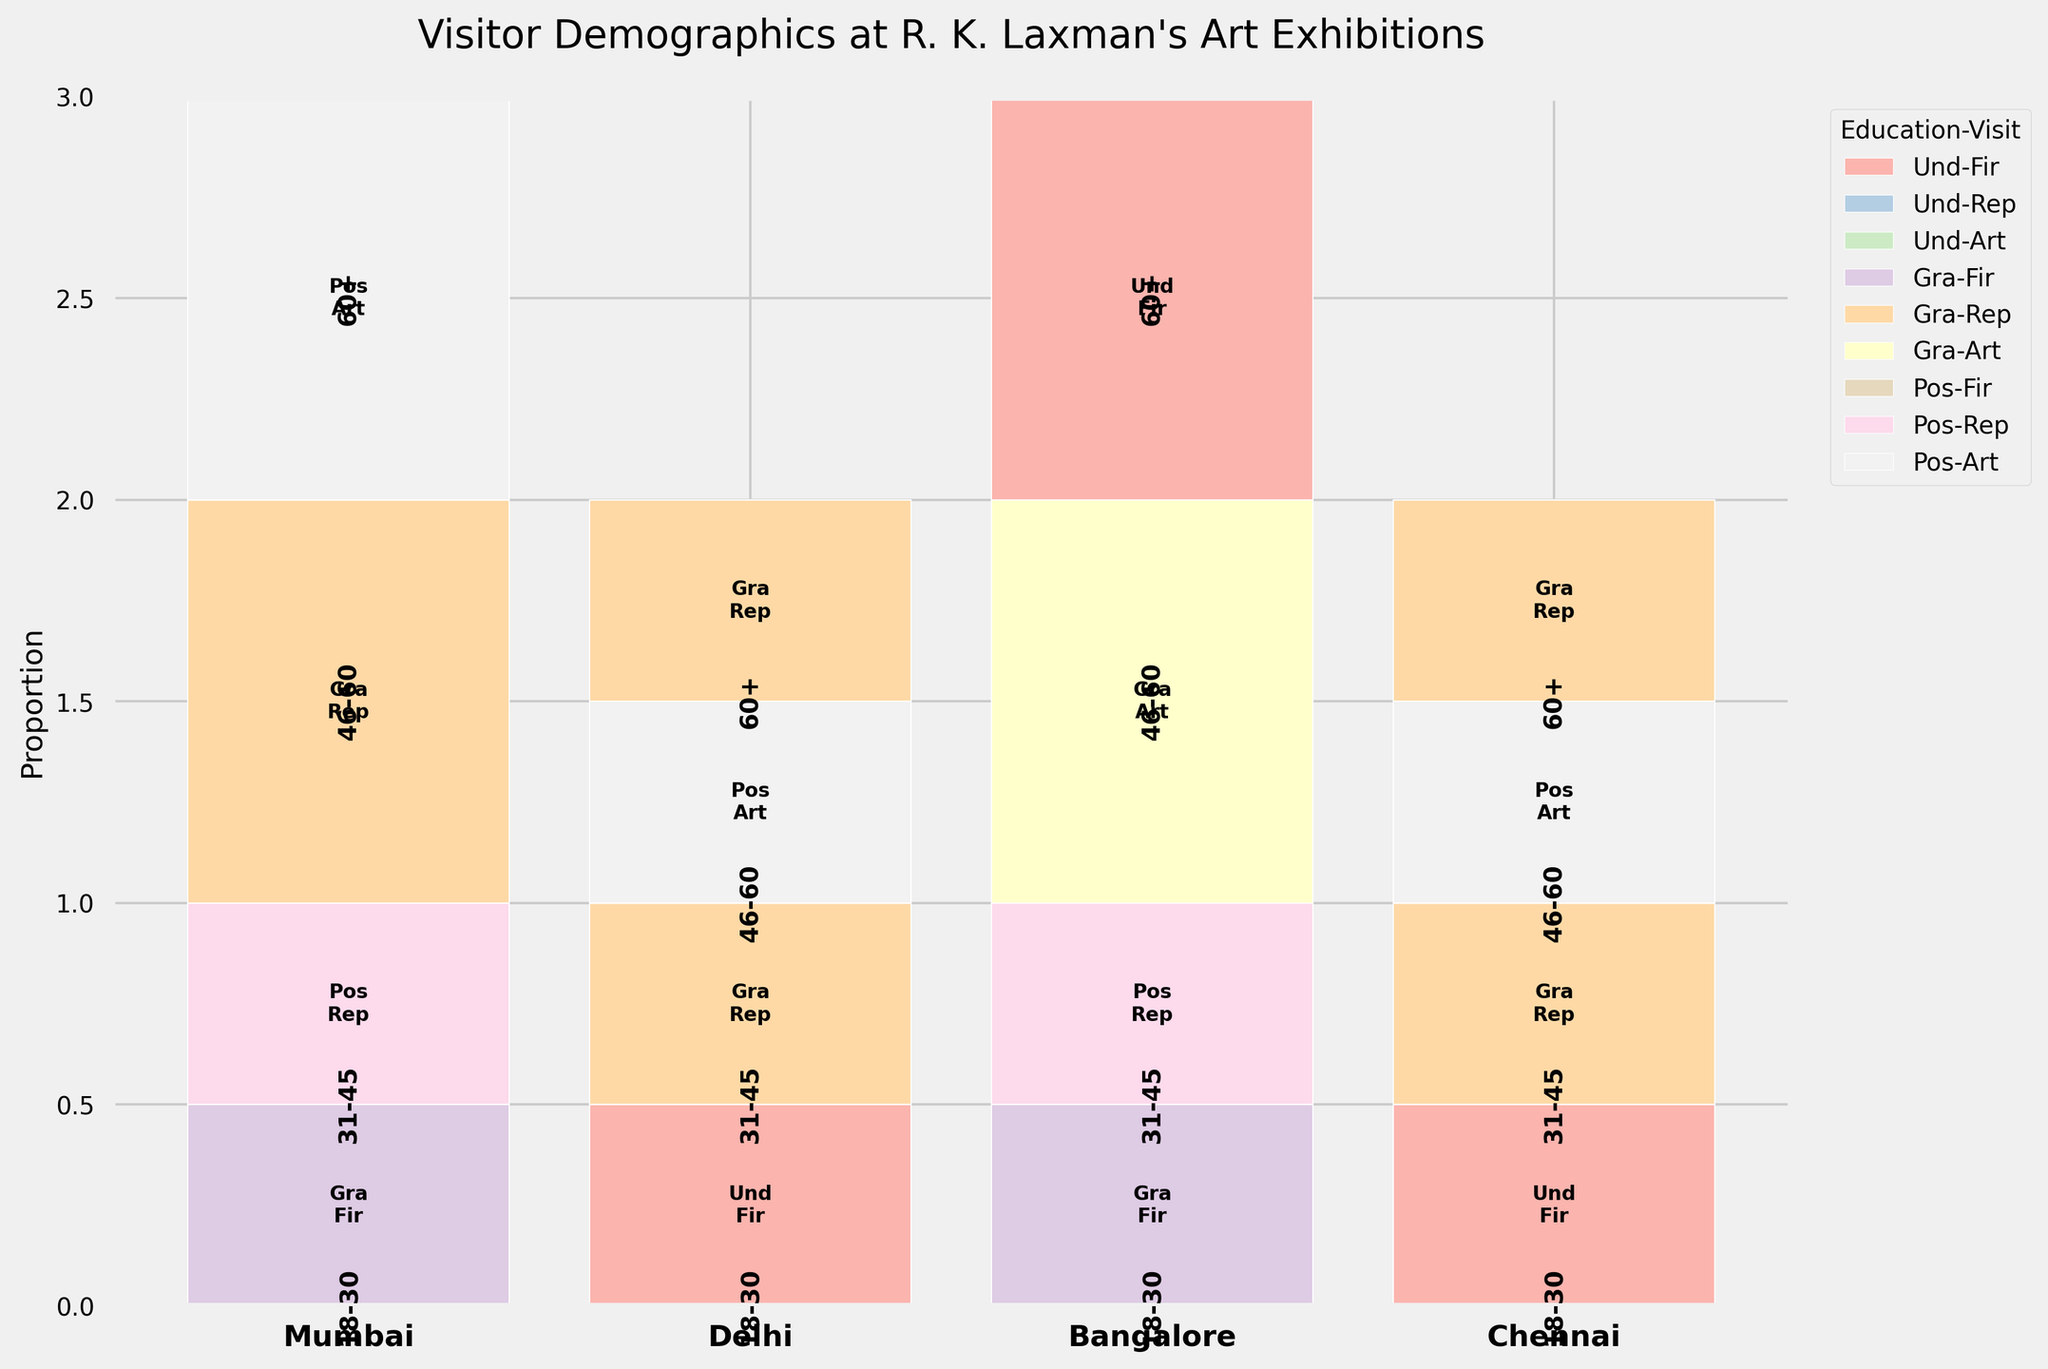What is the title of the plot? The title of the plot is usually displayed at the top of the figure. For this plot, it describes the subject of the visualization.
Answer: Visitor Demographics at R. K. Laxman's Art Exhibitions Which city has the highest proportion of visitors in the '18-30' age group? By examining the plot, look at the bar segments labeled '18-30' for each city. Identify the city with the largest segment.
Answer: Chennai What education and visit category combination appears most frequently across all cities? Analyze the various segments in all bars to find the category that reoccurs most frequently. Focus on the colors and labels that appear most often.
Answer: Graduate - First_Time In Mumbai, which age group has the most 'Repeat_Visitor'? Look at the Mumbai segment and identify which of the segments for the different age groups has the largest part colored and labeled as 'Repeat_Visitor'.
Answer: 31-45 What is the smallest age group category proportion in Delhi? By referring to the proportions labelled under each age group in Delhi, find the smallest segment.
Answer: 18-30 How many age groups have 'Art_Enthusiast' visitors in Bangalore? Check the segments in Bangalore city and count how many of the different age group segments are labeled 'Art_Enthusiast'.
Answer: 2 Which city has the largest 'Postgraduate' visitors proportion in the '60+' age group? Look for segments corresponding to '60+' age group in each city and identify the largest segment labeled 'Postgraduate'.
Answer: Mumbai Compare the proportion of 'Undergraduate' visitors in '18-30' age group between Delhi and Bangalore. Which city has a higher proportion? Locate the 'Undergraduate' visitor segments within the '18-30' age groups for both Delhi and Bangalore and compare the heights of these segments.
Answer: Delhi Is the 'Graduate' education level most common among 'Repeat_Visitor' in Chennai? Analyze the segments under Chennai city to determine if 'Graduate' labeled segments for 'Repeat_Visitor' are more frequent compared to others.
Answer: Yes 